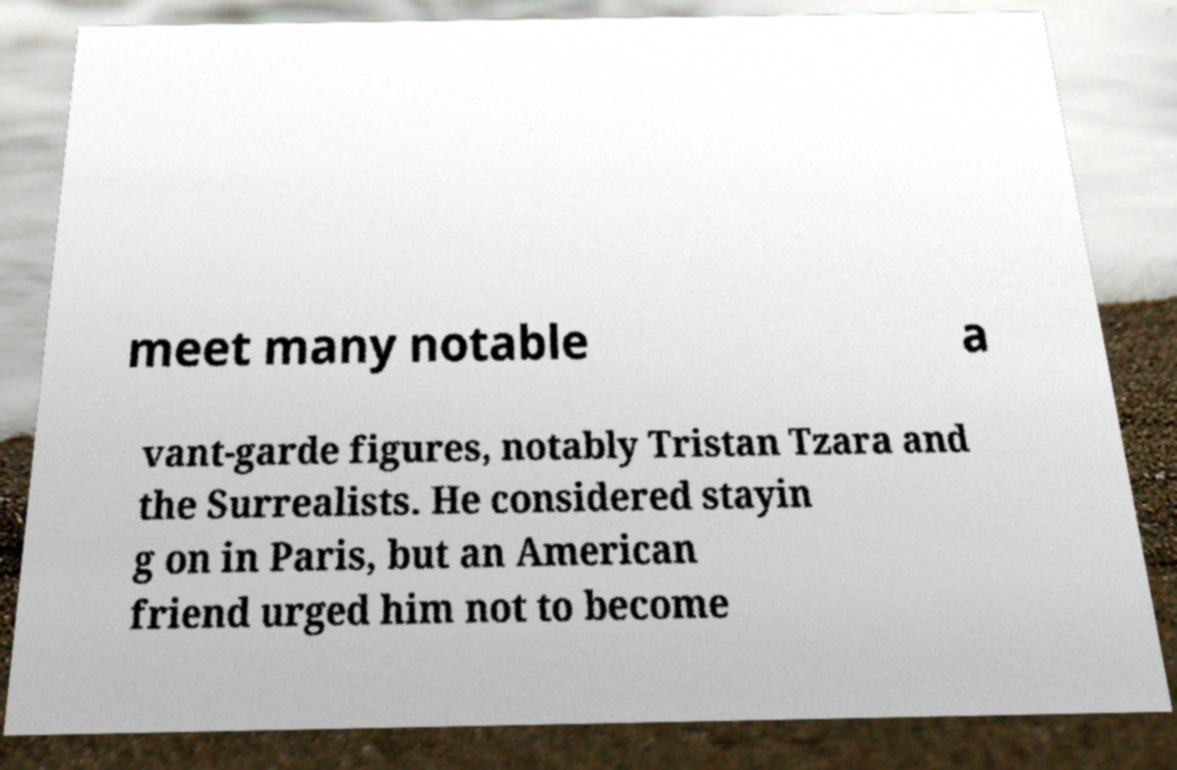Can you accurately transcribe the text from the provided image for me? meet many notable a vant-garde figures, notably Tristan Tzara and the Surrealists. He considered stayin g on in Paris, but an American friend urged him not to become 